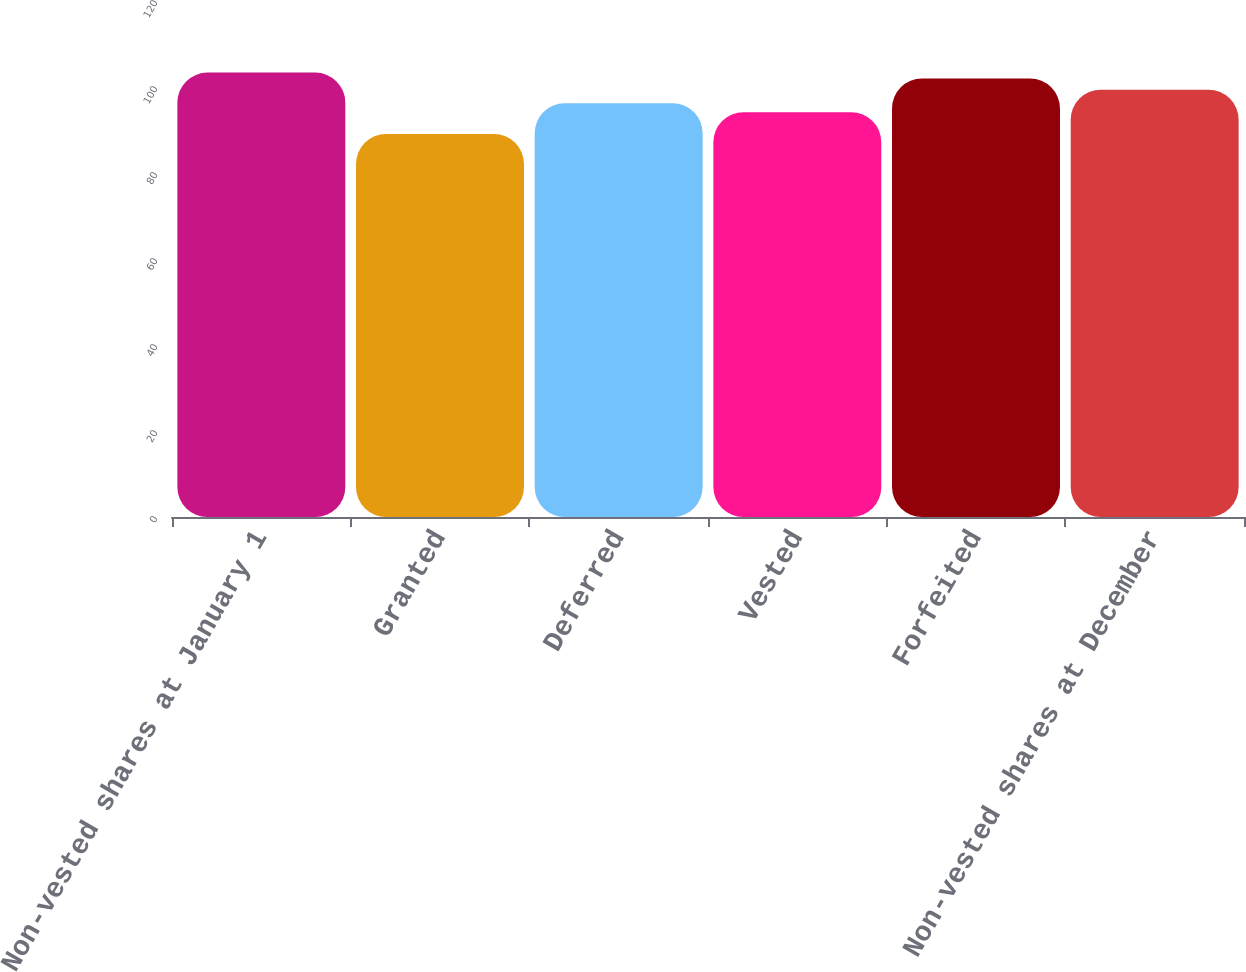Convert chart to OTSL. <chart><loc_0><loc_0><loc_500><loc_500><bar_chart><fcel>Non-vested shares at January 1<fcel>Granted<fcel>Deferred<fcel>Vested<fcel>Forfeited<fcel>Non-vested shares at December<nl><fcel>103.35<fcel>89.07<fcel>96.22<fcel>94.15<fcel>101.96<fcel>99.37<nl></chart> 